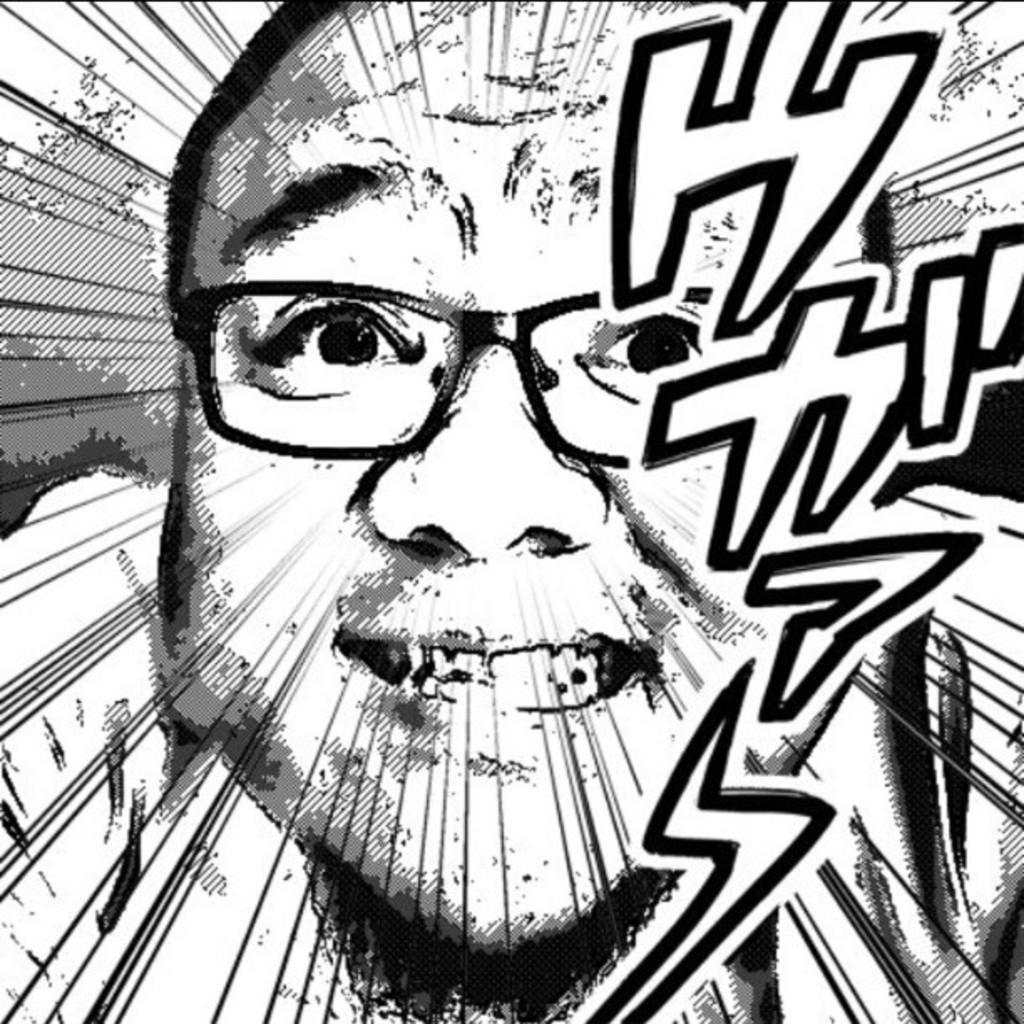What is depicted in the image? There is a sketch of a man in the image. What historical event is the man in the image participating in? The image does not depict a historical event or any specific context, so it is not possible to determine what historical event the man might be participating in. 